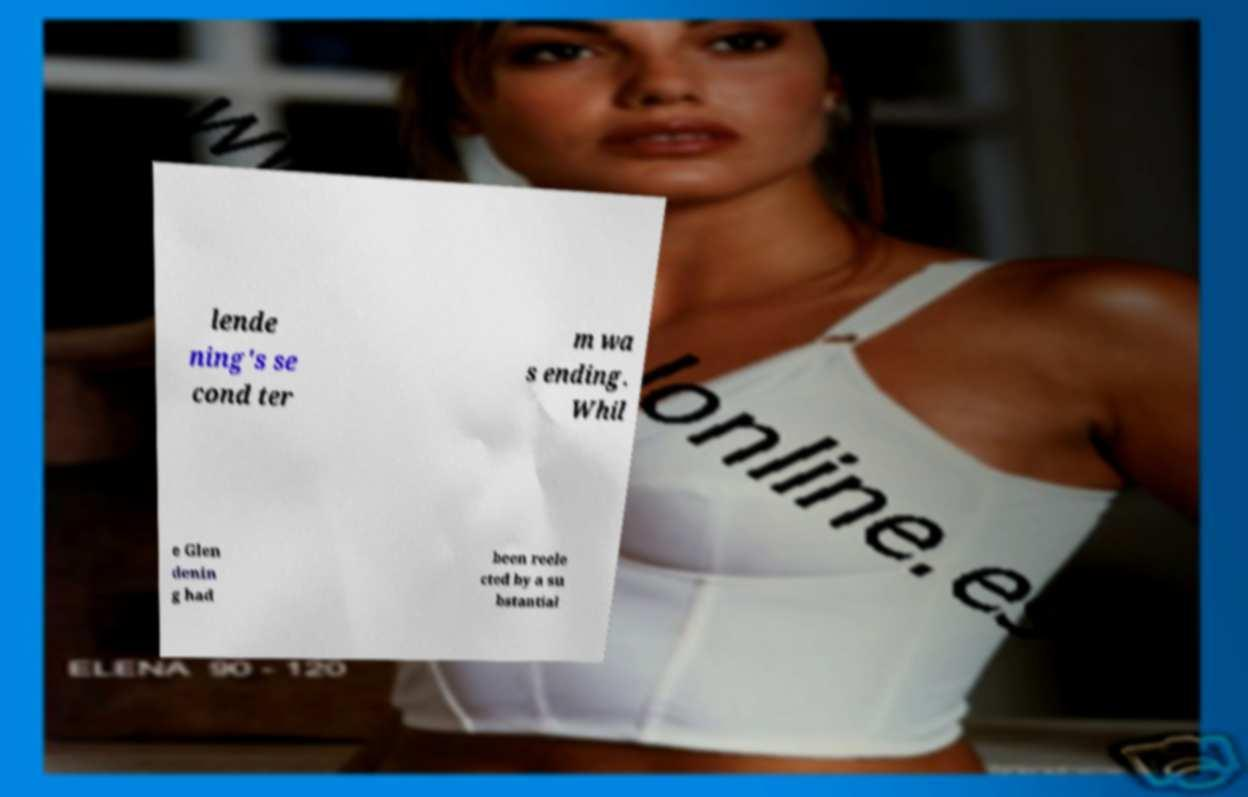Could you assist in decoding the text presented in this image and type it out clearly? lende ning's se cond ter m wa s ending. Whil e Glen denin g had been reele cted by a su bstantial 